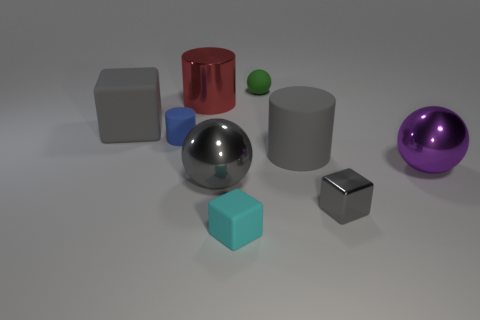Is the number of large gray metal objects greater than the number of small blue balls?
Provide a short and direct response. Yes. There is a small matte thing that is right of the cyan thing; is its shape the same as the cyan object?
Your answer should be very brief. No. How many objects are right of the large gray block and on the left side of the tiny cyan object?
Your answer should be compact. 3. How many other tiny things are the same shape as the tiny shiny thing?
Offer a very short reply. 1. The tiny matte thing that is in front of the large metal ball to the left of the matte ball is what color?
Offer a very short reply. Cyan. Is the shape of the green thing the same as the big metallic thing in front of the purple shiny thing?
Your answer should be very brief. Yes. The cube that is behind the ball that is on the right side of the cylinder that is to the right of the tiny cyan cube is made of what material?
Provide a short and direct response. Rubber. Are there any rubber things that have the same size as the gray ball?
Make the answer very short. Yes. There is a blue cylinder that is the same material as the small sphere; what size is it?
Give a very brief answer. Small. There is a big red object; what shape is it?
Your response must be concise. Cylinder. 